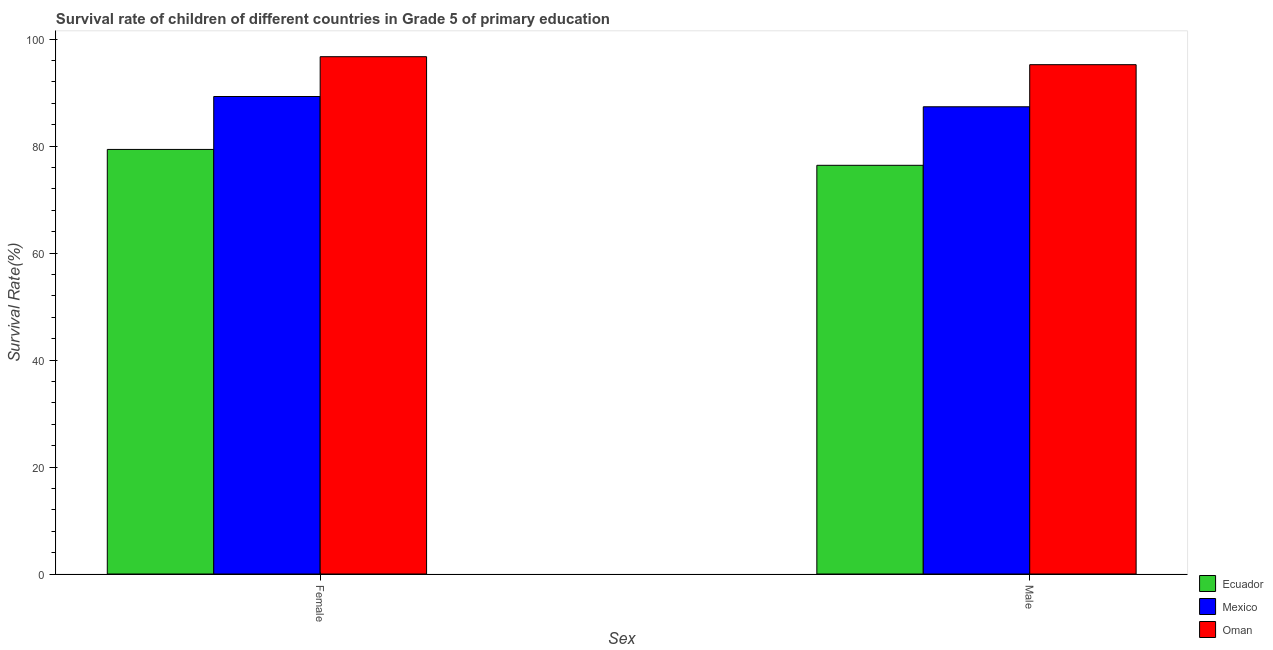How many different coloured bars are there?
Make the answer very short. 3. How many groups of bars are there?
Make the answer very short. 2. Are the number of bars on each tick of the X-axis equal?
Offer a terse response. Yes. What is the survival rate of male students in primary education in Ecuador?
Give a very brief answer. 76.4. Across all countries, what is the maximum survival rate of female students in primary education?
Provide a short and direct response. 96.71. Across all countries, what is the minimum survival rate of male students in primary education?
Your answer should be compact. 76.4. In which country was the survival rate of male students in primary education maximum?
Keep it short and to the point. Oman. In which country was the survival rate of male students in primary education minimum?
Make the answer very short. Ecuador. What is the total survival rate of male students in primary education in the graph?
Provide a succinct answer. 258.97. What is the difference between the survival rate of female students in primary education in Mexico and that in Oman?
Offer a terse response. -7.44. What is the difference between the survival rate of male students in primary education in Ecuador and the survival rate of female students in primary education in Oman?
Give a very brief answer. -20.31. What is the average survival rate of male students in primary education per country?
Ensure brevity in your answer.  86.32. What is the difference between the survival rate of male students in primary education and survival rate of female students in primary education in Mexico?
Your answer should be very brief. -1.92. In how many countries, is the survival rate of female students in primary education greater than 40 %?
Give a very brief answer. 3. What is the ratio of the survival rate of female students in primary education in Mexico to that in Oman?
Provide a short and direct response. 0.92. Is the survival rate of female students in primary education in Mexico less than that in Ecuador?
Provide a short and direct response. No. What does the 3rd bar from the left in Female represents?
Provide a succinct answer. Oman. What does the 1st bar from the right in Male represents?
Make the answer very short. Oman. How many bars are there?
Your response must be concise. 6. What is the difference between two consecutive major ticks on the Y-axis?
Your response must be concise. 20. Where does the legend appear in the graph?
Keep it short and to the point. Bottom right. What is the title of the graph?
Keep it short and to the point. Survival rate of children of different countries in Grade 5 of primary education. What is the label or title of the X-axis?
Provide a short and direct response. Sex. What is the label or title of the Y-axis?
Your answer should be very brief. Survival Rate(%). What is the Survival Rate(%) in Ecuador in Female?
Offer a terse response. 79.37. What is the Survival Rate(%) in Mexico in Female?
Provide a succinct answer. 89.27. What is the Survival Rate(%) of Oman in Female?
Provide a short and direct response. 96.71. What is the Survival Rate(%) of Ecuador in Male?
Your answer should be very brief. 76.4. What is the Survival Rate(%) of Mexico in Male?
Offer a terse response. 87.35. What is the Survival Rate(%) in Oman in Male?
Your answer should be very brief. 95.22. Across all Sex, what is the maximum Survival Rate(%) of Ecuador?
Keep it short and to the point. 79.37. Across all Sex, what is the maximum Survival Rate(%) of Mexico?
Provide a short and direct response. 89.27. Across all Sex, what is the maximum Survival Rate(%) in Oman?
Provide a succinct answer. 96.71. Across all Sex, what is the minimum Survival Rate(%) in Ecuador?
Your response must be concise. 76.4. Across all Sex, what is the minimum Survival Rate(%) of Mexico?
Your answer should be very brief. 87.35. Across all Sex, what is the minimum Survival Rate(%) in Oman?
Provide a succinct answer. 95.22. What is the total Survival Rate(%) in Ecuador in the graph?
Make the answer very short. 155.78. What is the total Survival Rate(%) in Mexico in the graph?
Your response must be concise. 176.61. What is the total Survival Rate(%) in Oman in the graph?
Offer a terse response. 191.93. What is the difference between the Survival Rate(%) in Ecuador in Female and that in Male?
Your answer should be compact. 2.97. What is the difference between the Survival Rate(%) in Mexico in Female and that in Male?
Make the answer very short. 1.92. What is the difference between the Survival Rate(%) of Oman in Female and that in Male?
Ensure brevity in your answer.  1.49. What is the difference between the Survival Rate(%) in Ecuador in Female and the Survival Rate(%) in Mexico in Male?
Make the answer very short. -7.97. What is the difference between the Survival Rate(%) of Ecuador in Female and the Survival Rate(%) of Oman in Male?
Provide a short and direct response. -15.84. What is the difference between the Survival Rate(%) of Mexico in Female and the Survival Rate(%) of Oman in Male?
Ensure brevity in your answer.  -5.95. What is the average Survival Rate(%) in Ecuador per Sex?
Make the answer very short. 77.89. What is the average Survival Rate(%) in Mexico per Sex?
Your answer should be compact. 88.31. What is the average Survival Rate(%) of Oman per Sex?
Provide a short and direct response. 95.96. What is the difference between the Survival Rate(%) in Ecuador and Survival Rate(%) in Mexico in Female?
Your response must be concise. -9.89. What is the difference between the Survival Rate(%) in Ecuador and Survival Rate(%) in Oman in Female?
Ensure brevity in your answer.  -17.34. What is the difference between the Survival Rate(%) in Mexico and Survival Rate(%) in Oman in Female?
Give a very brief answer. -7.44. What is the difference between the Survival Rate(%) of Ecuador and Survival Rate(%) of Mexico in Male?
Provide a succinct answer. -10.94. What is the difference between the Survival Rate(%) of Ecuador and Survival Rate(%) of Oman in Male?
Make the answer very short. -18.81. What is the difference between the Survival Rate(%) in Mexico and Survival Rate(%) in Oman in Male?
Make the answer very short. -7.87. What is the ratio of the Survival Rate(%) in Ecuador in Female to that in Male?
Ensure brevity in your answer.  1.04. What is the ratio of the Survival Rate(%) in Oman in Female to that in Male?
Keep it short and to the point. 1.02. What is the difference between the highest and the second highest Survival Rate(%) in Ecuador?
Offer a very short reply. 2.97. What is the difference between the highest and the second highest Survival Rate(%) of Mexico?
Your answer should be compact. 1.92. What is the difference between the highest and the second highest Survival Rate(%) in Oman?
Keep it short and to the point. 1.49. What is the difference between the highest and the lowest Survival Rate(%) in Ecuador?
Keep it short and to the point. 2.97. What is the difference between the highest and the lowest Survival Rate(%) in Mexico?
Make the answer very short. 1.92. What is the difference between the highest and the lowest Survival Rate(%) in Oman?
Provide a succinct answer. 1.49. 